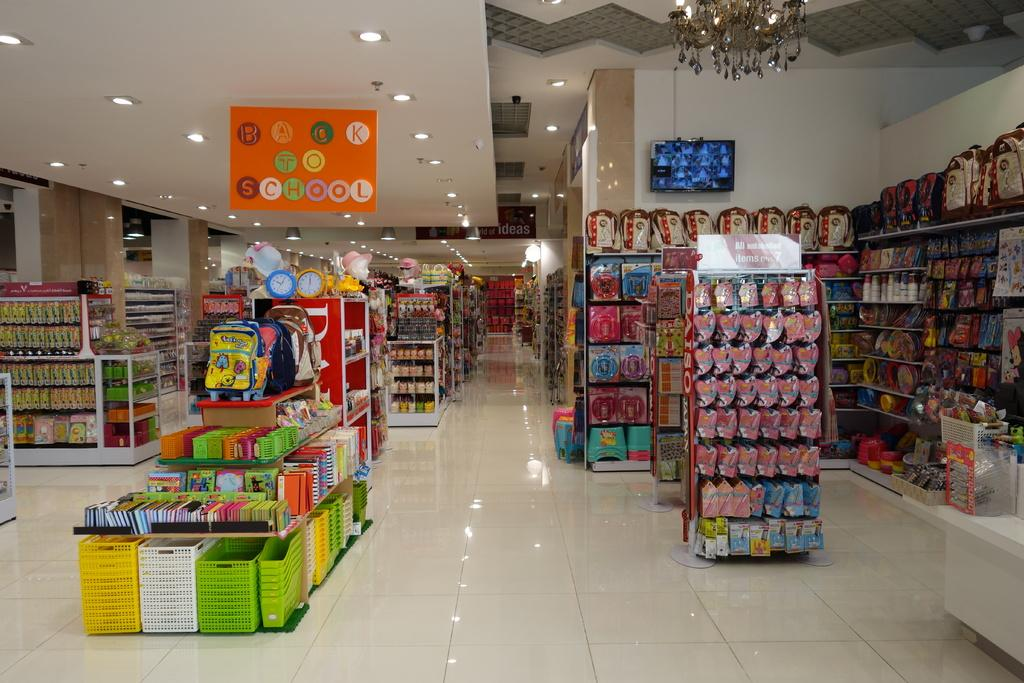<image>
Render a clear and concise summary of the photo. A store with displays and a sign above them saying "Back to School." 